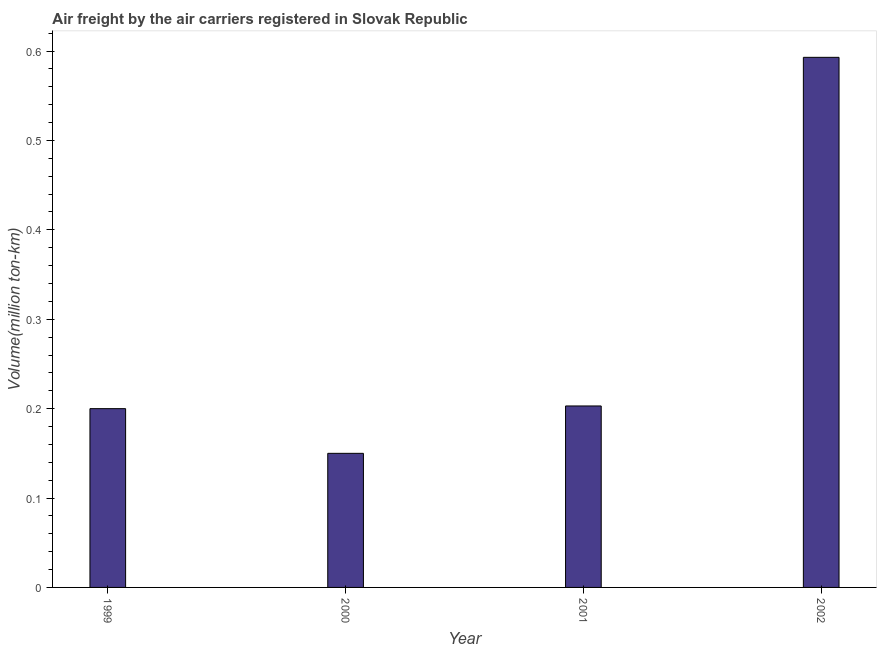Does the graph contain any zero values?
Provide a short and direct response. No. What is the title of the graph?
Provide a succinct answer. Air freight by the air carriers registered in Slovak Republic. What is the label or title of the Y-axis?
Your answer should be very brief. Volume(million ton-km). What is the air freight in 2001?
Offer a very short reply. 0.2. Across all years, what is the maximum air freight?
Ensure brevity in your answer.  0.59. Across all years, what is the minimum air freight?
Your answer should be compact. 0.15. In which year was the air freight maximum?
Provide a succinct answer. 2002. What is the sum of the air freight?
Offer a terse response. 1.15. What is the difference between the air freight in 2000 and 2001?
Your answer should be compact. -0.05. What is the average air freight per year?
Ensure brevity in your answer.  0.29. What is the median air freight?
Offer a very short reply. 0.2. In how many years, is the air freight greater than 0.3 million ton-km?
Provide a succinct answer. 1. Do a majority of the years between 2002 and 2001 (inclusive) have air freight greater than 0.42 million ton-km?
Your answer should be very brief. No. What is the ratio of the air freight in 1999 to that in 2000?
Your answer should be very brief. 1.33. Is the air freight in 1999 less than that in 2002?
Your response must be concise. Yes. What is the difference between the highest and the second highest air freight?
Offer a very short reply. 0.39. Is the sum of the air freight in 2000 and 2001 greater than the maximum air freight across all years?
Your response must be concise. No. What is the difference between the highest and the lowest air freight?
Your response must be concise. 0.44. In how many years, is the air freight greater than the average air freight taken over all years?
Provide a short and direct response. 1. Are the values on the major ticks of Y-axis written in scientific E-notation?
Your answer should be very brief. No. What is the Volume(million ton-km) of 1999?
Ensure brevity in your answer.  0.2. What is the Volume(million ton-km) in 2000?
Provide a short and direct response. 0.15. What is the Volume(million ton-km) of 2001?
Provide a short and direct response. 0.2. What is the Volume(million ton-km) of 2002?
Keep it short and to the point. 0.59. What is the difference between the Volume(million ton-km) in 1999 and 2001?
Your answer should be compact. -0. What is the difference between the Volume(million ton-km) in 1999 and 2002?
Provide a succinct answer. -0.39. What is the difference between the Volume(million ton-km) in 2000 and 2001?
Your answer should be compact. -0.05. What is the difference between the Volume(million ton-km) in 2000 and 2002?
Offer a terse response. -0.44. What is the difference between the Volume(million ton-km) in 2001 and 2002?
Your answer should be very brief. -0.39. What is the ratio of the Volume(million ton-km) in 1999 to that in 2000?
Provide a succinct answer. 1.33. What is the ratio of the Volume(million ton-km) in 1999 to that in 2002?
Offer a terse response. 0.34. What is the ratio of the Volume(million ton-km) in 2000 to that in 2001?
Keep it short and to the point. 0.74. What is the ratio of the Volume(million ton-km) in 2000 to that in 2002?
Your answer should be very brief. 0.25. What is the ratio of the Volume(million ton-km) in 2001 to that in 2002?
Ensure brevity in your answer.  0.34. 